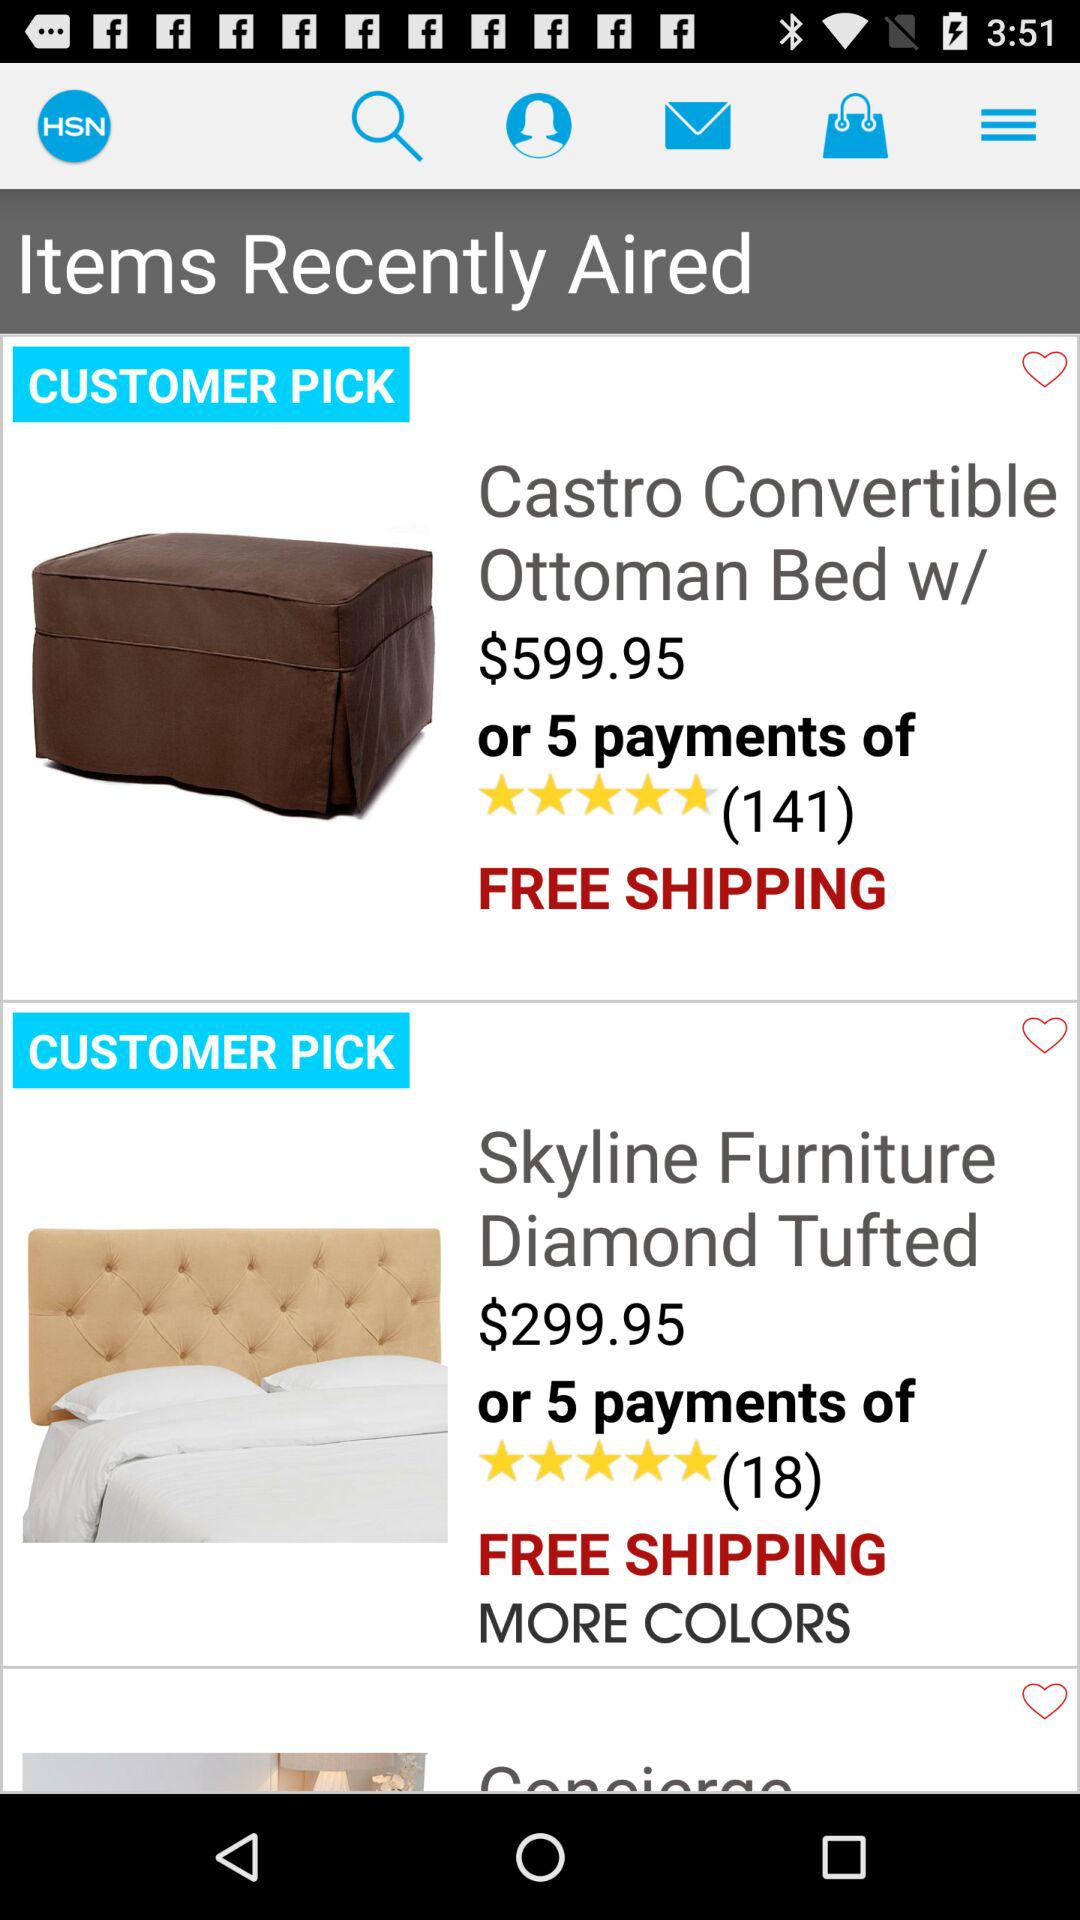What is the shipping cost for the "Castro Convertible Ottoman Bed"? The shipping cost is free. 